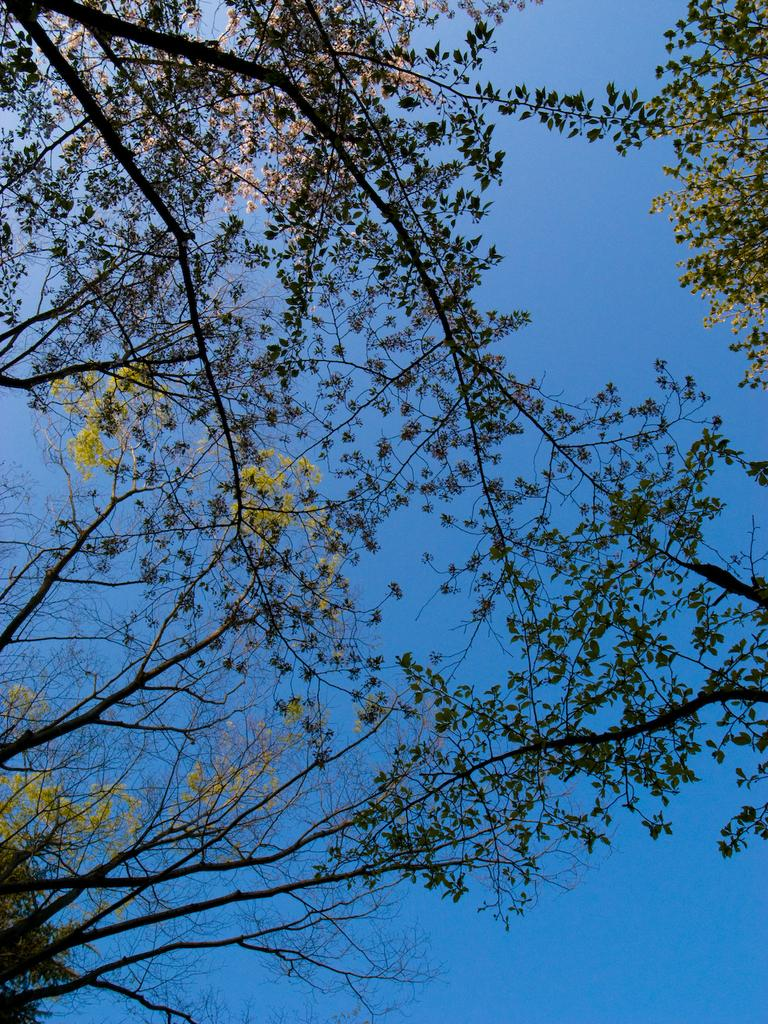What type of vegetation is present in the image? There are green trees in the image. What color is the sky in the image? The sky is blue in the image. What type of ice can be seen melting on the trees in the image? There is no ice present on the trees in the image; they are green. What stage of development is the city shown in the image? There is no city or development shown in the image; it features green trees and a blue sky. 